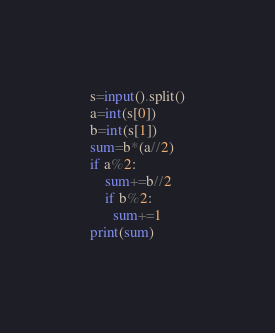Convert code to text. <code><loc_0><loc_0><loc_500><loc_500><_Python_>s=input().split()
a=int(s[0])
b=int(s[1])
sum=b*(a//2)
if a%2:
    sum+=b//2
    if b%2:
      sum+=1
print(sum)</code> 